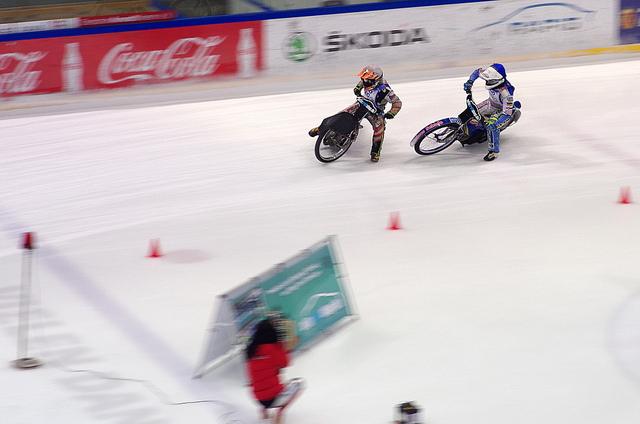Who rides the bike?
Answer briefly. People. Are the bike outside?
Answer briefly. Yes. Are they riding bikes on ice?
Answer briefly. Yes. 